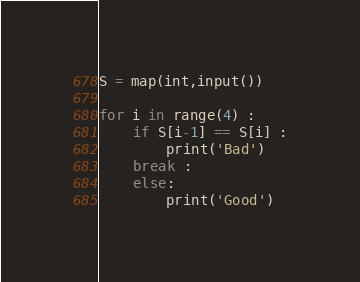Convert code to text. <code><loc_0><loc_0><loc_500><loc_500><_Python_>S = map(int,input())

for i in range(4) :
	if S[i-1] == S[i] :
		print('Bad')
	break :
	else: 
		print('Good')</code> 